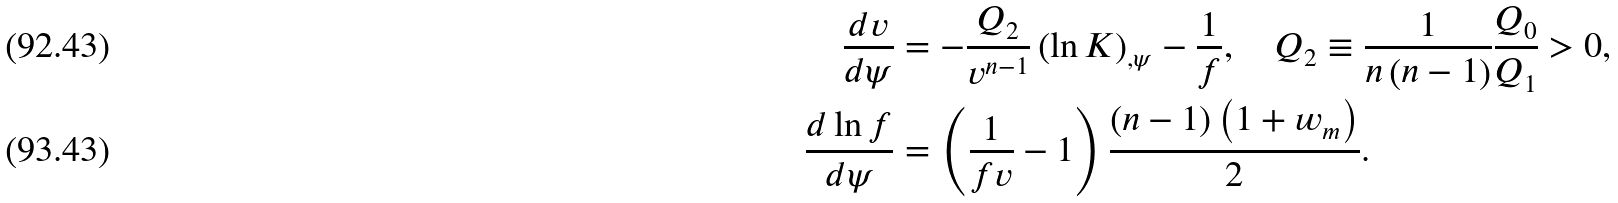<formula> <loc_0><loc_0><loc_500><loc_500>\frac { d v } { d \psi } & = - \frac { Q _ { 2 } } { v ^ { n - 1 } } \left ( \ln K \right ) _ { , \psi } - \frac { 1 } { f } , \quad Q _ { 2 } \equiv \frac { 1 } { n \left ( n - 1 \right ) } \frac { Q _ { 0 } } { Q _ { 1 } } > 0 , \\ \frac { d \ln f } { d \psi } & = \left ( \frac { 1 } { f v } - 1 \right ) \frac { \left ( n - 1 \right ) \left ( 1 + w _ { m } \right ) } { 2 } .</formula> 